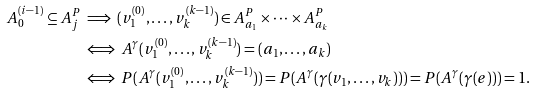<formula> <loc_0><loc_0><loc_500><loc_500>A _ { 0 } ^ { ( i - 1 ) } \subseteq A ^ { P } _ { j } & \implies ( v _ { 1 } ^ { ( 0 ) } , \dots , v _ { k } ^ { ( k - 1 ) } ) \in A ^ { P } _ { a _ { 1 } } \times \dots \times A ^ { P } _ { a _ { k } } \\ & \iff A ^ { \gamma } ( v _ { 1 } ^ { ( 0 ) } , \dots , v _ { k } ^ { ( k - 1 ) } ) = ( a _ { 1 } , \dots , a _ { k } ) \\ & \iff P ( A ^ { \gamma } ( v _ { 1 } ^ { ( 0 ) } , \dots , v _ { k } ^ { ( k - 1 ) } ) ) = P ( A ^ { \gamma } ( \gamma ( v _ { 1 } , \dots , v _ { k } ) ) ) = P ( A ^ { \gamma } ( \gamma ( e ) ) ) = 1 .</formula> 